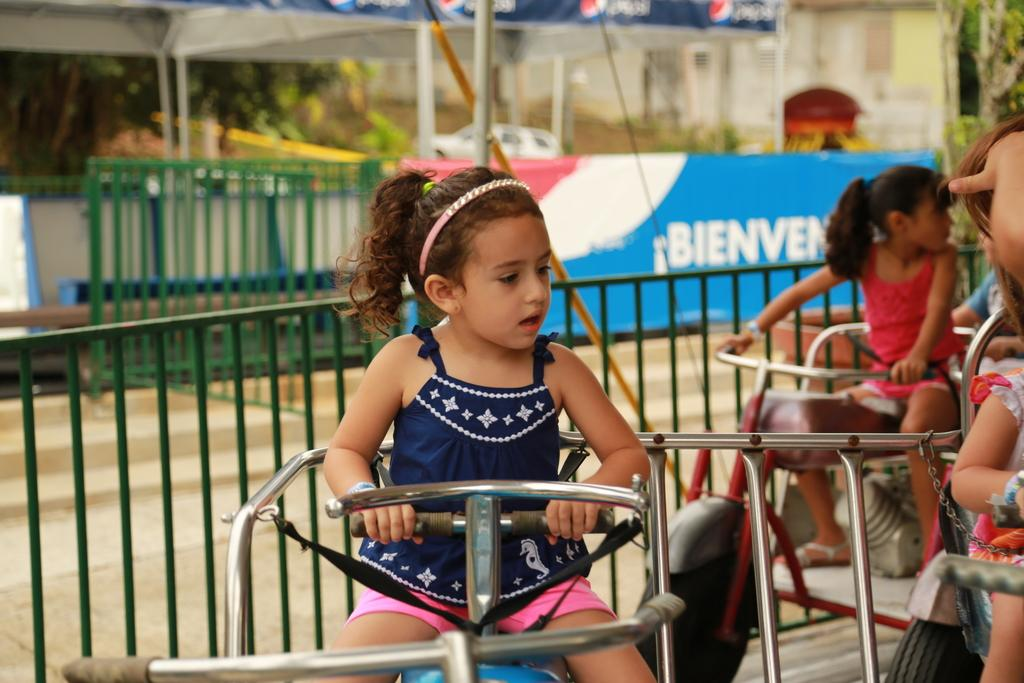What are the kids doing in the image? The kids are riding in the image. Where is the scene taking place? The setting is an amusement park. What type of natural elements can be seen in the image? There are trees in the image. What type of structures are visible in the image? There are houses in the image. What type of barrier is present in the image? There is a fence in the image. What type of signage is present in the image? There is a board with text in the image. What type of transportation is visible in the image? Vehicles are visible in the image. How many rabbits can be seen hopping in the snow in the image? There are no rabbits or snow present in the image. 